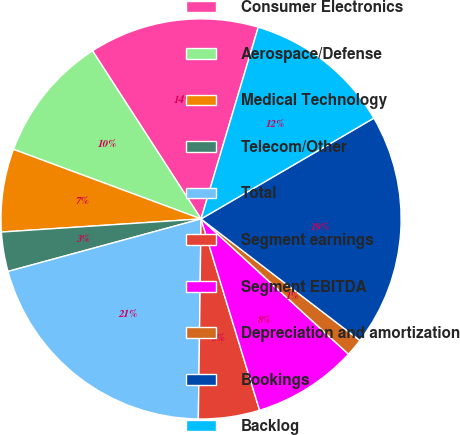Convert chart. <chart><loc_0><loc_0><loc_500><loc_500><pie_chart><fcel>Consumer Electronics<fcel>Aerospace/Defense<fcel>Medical Technology<fcel>Telecom/Other<fcel>Total<fcel>Segment earnings<fcel>Segment EBITDA<fcel>Depreciation and amortization<fcel>Bookings<fcel>Backlog<nl><fcel>13.74%<fcel>10.22%<fcel>6.7%<fcel>3.18%<fcel>20.56%<fcel>4.94%<fcel>8.46%<fcel>1.42%<fcel>18.8%<fcel>11.98%<nl></chart> 